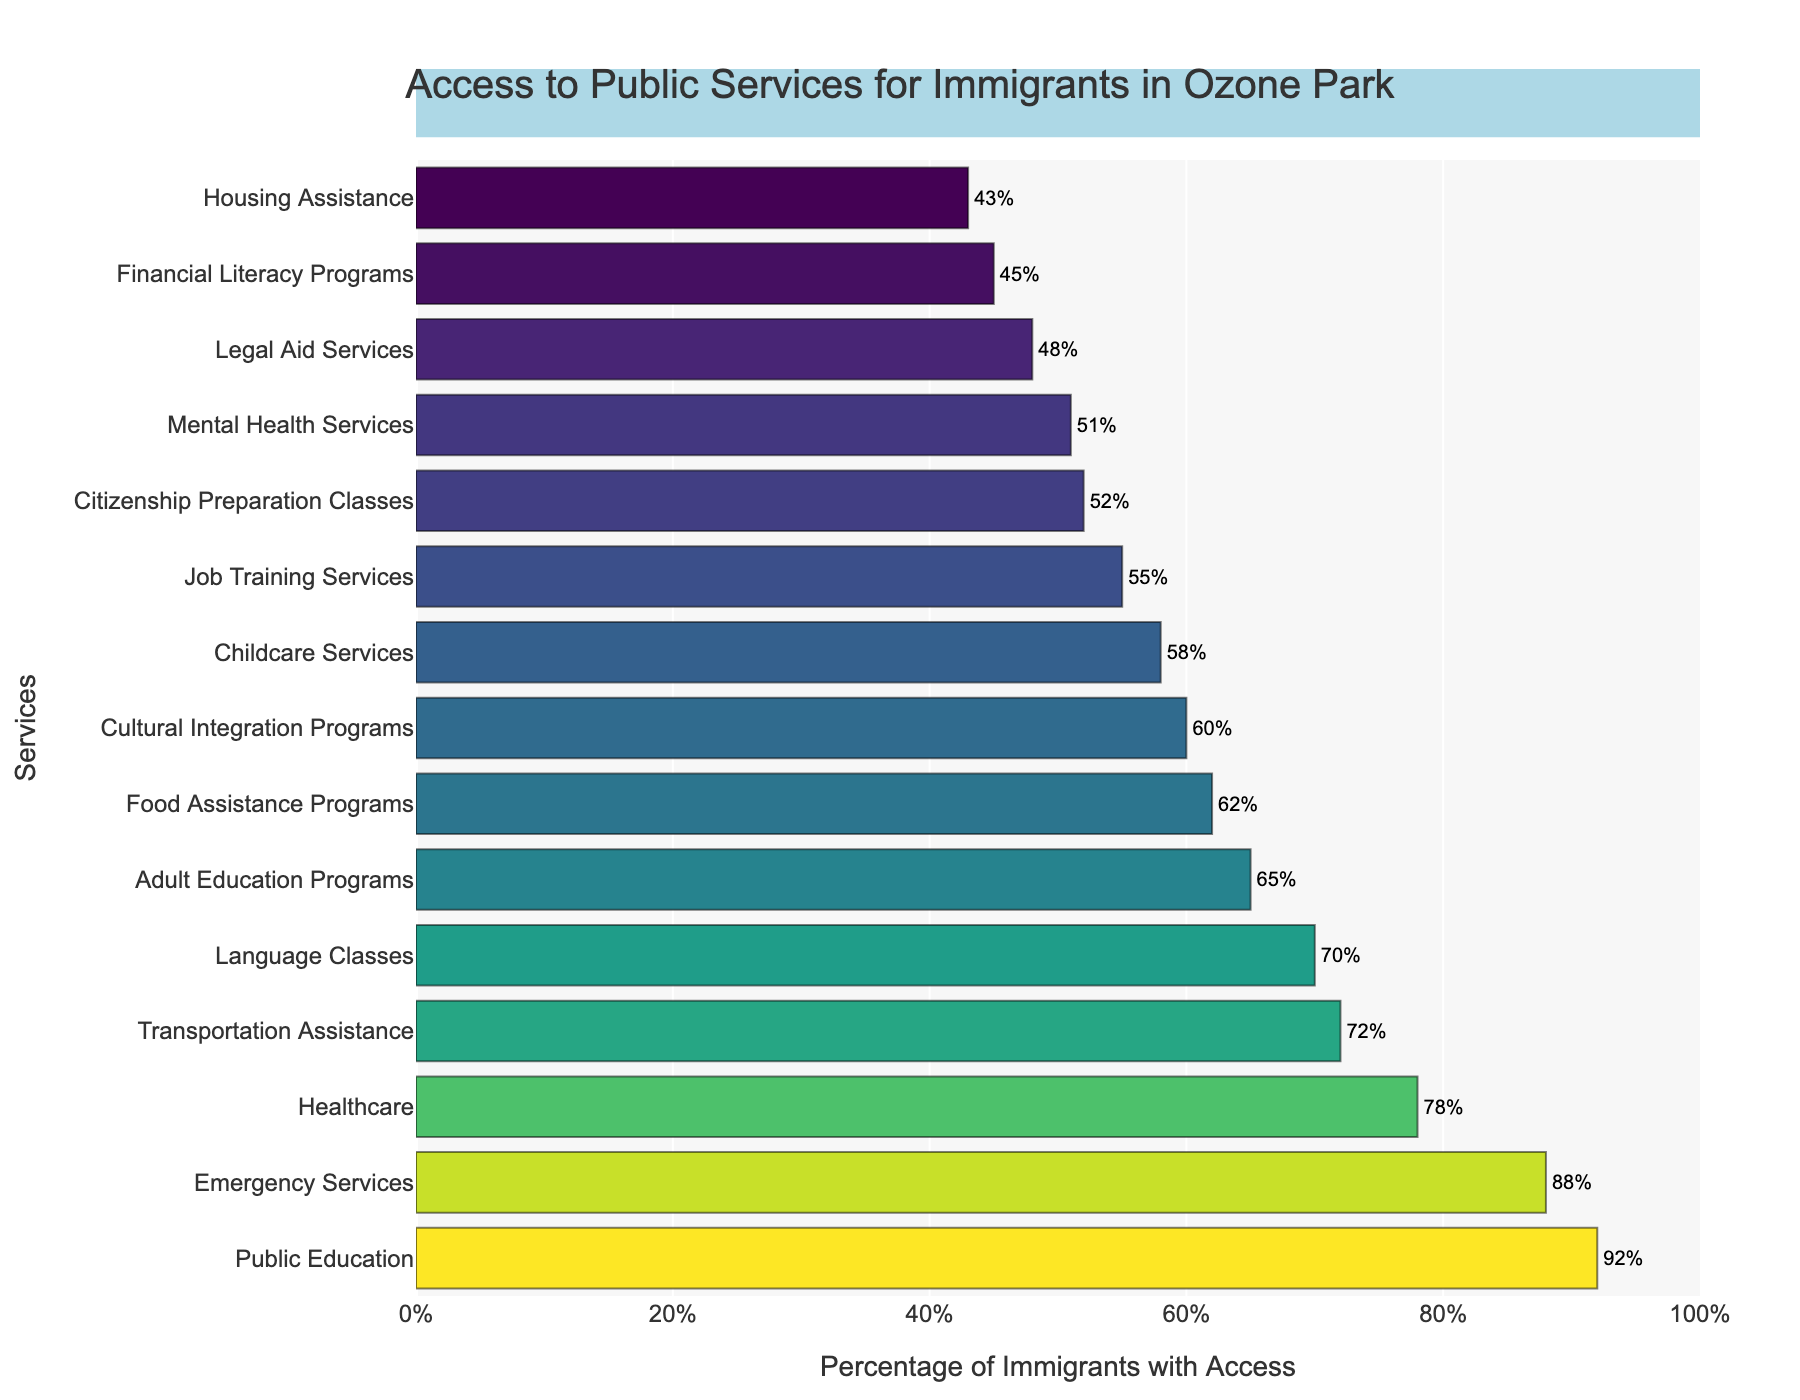Which service has the highest percentage of access among immigrants in Ozone Park? By looking at the bar chart, the tallest bar represents "Public Education" with a percentage of 92.
Answer: Public Education Which service has the lowest percentage of access among immigrants in Ozone Park? By looking at the bar chart, the shortest bar represents "Housing Assistance" with a percentage of 43.
Answer: Housing Assistance Which service has a higher percentage of access: Job Training Services or Citizenship Preparation Classes? Comparing the lengths of the bars for Job Training Services and Citizenship Preparation Classes, Job Training Services has 55%, while Citizenship Preparation Classes has 52%.
Answer: Job Training Services What is the sum of percentages of access for Healthcare, Public Education, and Emergency Services? Adding the percentages for Healthcare (78%), Public Education (92%), and Emergency Services (88%): 78 + 92 + 88 = 258.
Answer: 258 How much higher is the percentage of access to Language Classes compared to Job Training Services? Percentage of access to Language Classes is 70%, and for Job Training Services, it's 55%. The difference is 70 - 55 = 15.
Answer: 15 What is the average percentage of access to Financial Literacy Programs and Legal Aid Services? Adding the percentages for Financial Literacy Programs (45%) and Legal Aid Services (48%) and then dividing by 2: (45 + 48) / 2 = 46.5.
Answer: 46.5 Are there more immigrants with access to Mental Health Services or Childcare Services? Comparing the bars for Mental Health Services and Childcare Services, Mental Health Services has 51%, while Childcare Services has 58%.
Answer: Childcare Services Which service has nearly three-quarters of immigrants with access? Three-quarters is approximately 75%. The service closest to this is Transportation Assistance with 72%.
Answer: Transportation Assistance What is the difference in access percentage between Food Assistance Programs and Cultural Integration Programs? Percentage for Food Assistance Programs is 62%, and for Cultural Integration Programs, it's 60%. The difference is 62 - 60 = 2.
Answer: 2 What is the range (difference between highest and lowest) of access percentages for these services? The highest percentage is for Public Education (92%) and the lowest is for Housing Assistance (43%). The range is 92 - 43 = 49.
Answer: 49 